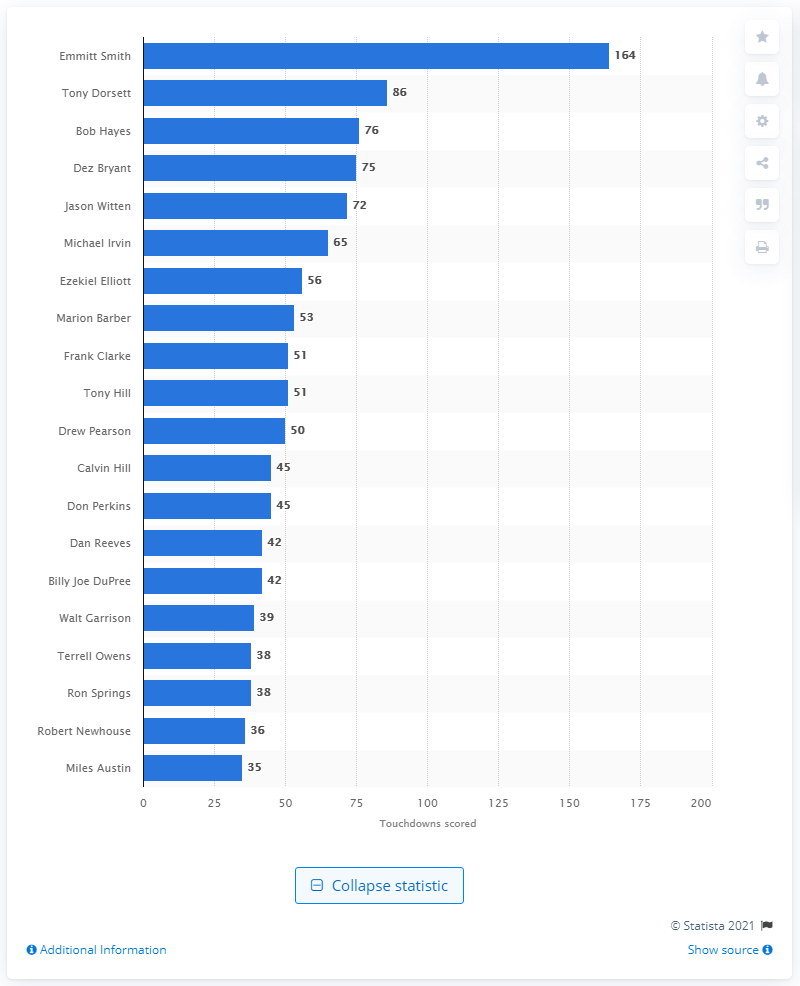Outline some significant characteristics in this image. Emmitt Smith is the career touchdown leader of the Dallas Cowboys. 